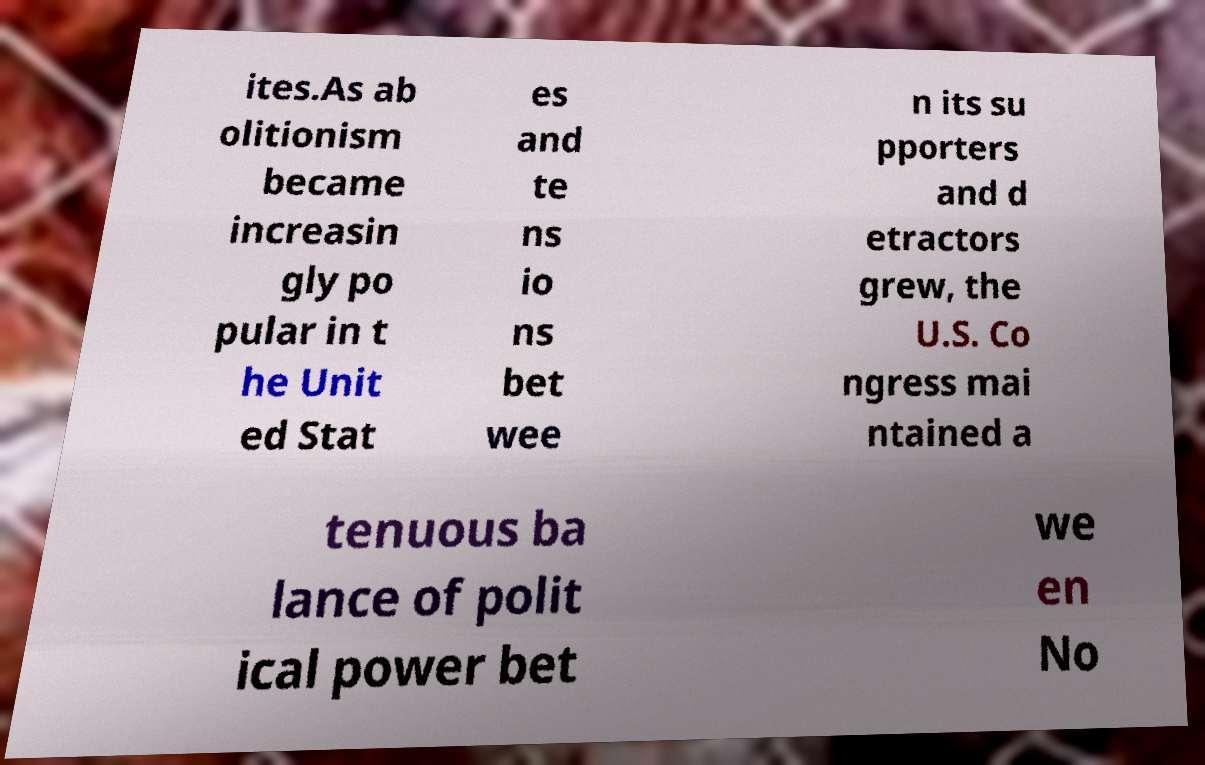I need the written content from this picture converted into text. Can you do that? ites.As ab olitionism became increasin gly po pular in t he Unit ed Stat es and te ns io ns bet wee n its su pporters and d etractors grew, the U.S. Co ngress mai ntained a tenuous ba lance of polit ical power bet we en No 